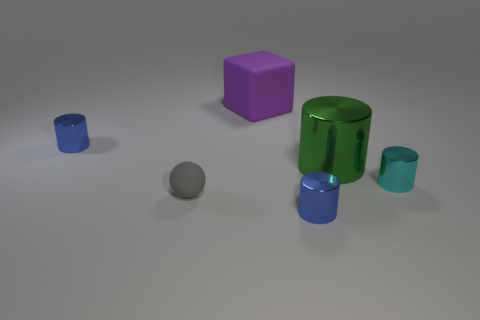Do the big green metallic object and the cyan metallic thing have the same shape?
Your response must be concise. Yes. How many objects are either large yellow metallic blocks or large green shiny cylinders?
Your response must be concise. 1. The large cylinder that is the same material as the tiny cyan thing is what color?
Keep it short and to the point. Green. Is the shape of the blue thing in front of the cyan object the same as  the green object?
Keep it short and to the point. Yes. What number of objects are either small blue things that are in front of the tiny gray thing or small metal cylinders left of the gray rubber object?
Ensure brevity in your answer.  2. Are there any other things that are the same shape as the large purple matte object?
Give a very brief answer. No. Does the large purple thing have the same shape as the tiny object behind the tiny cyan shiny object?
Provide a succinct answer. No. What is the green object made of?
Offer a very short reply. Metal. The green metallic object that is the same shape as the cyan metallic thing is what size?
Offer a very short reply. Large. What number of other objects are there of the same material as the gray ball?
Provide a succinct answer. 1. 